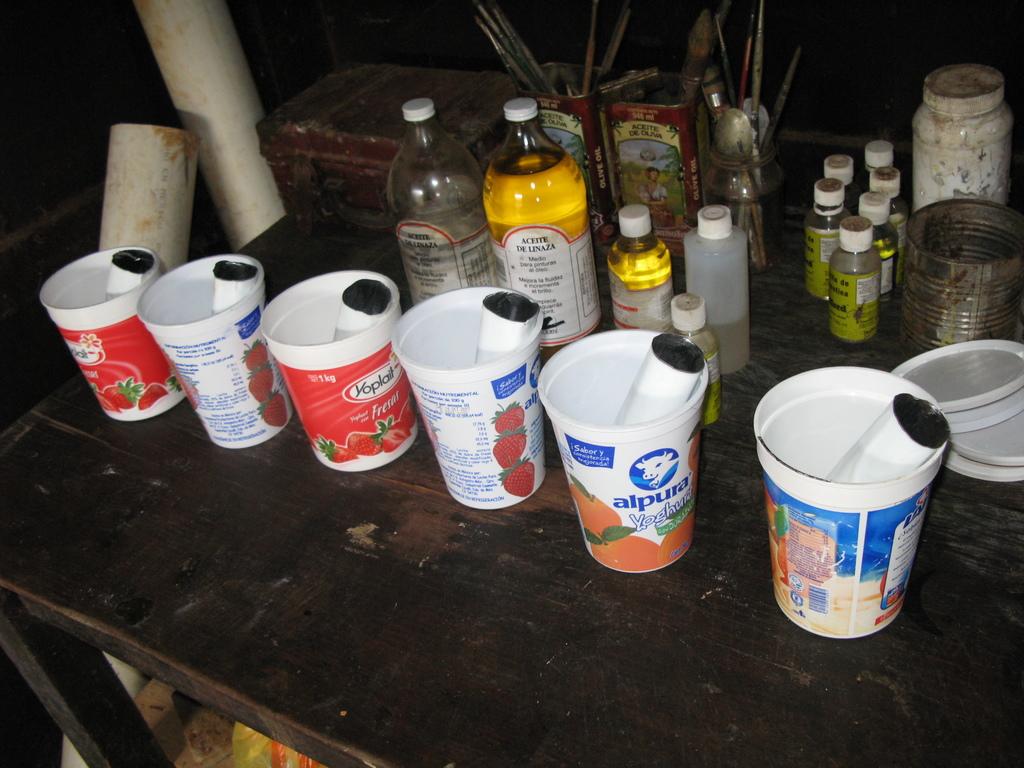Who makes the yogurt in the red cup?
Offer a terse response. Yoplait. 